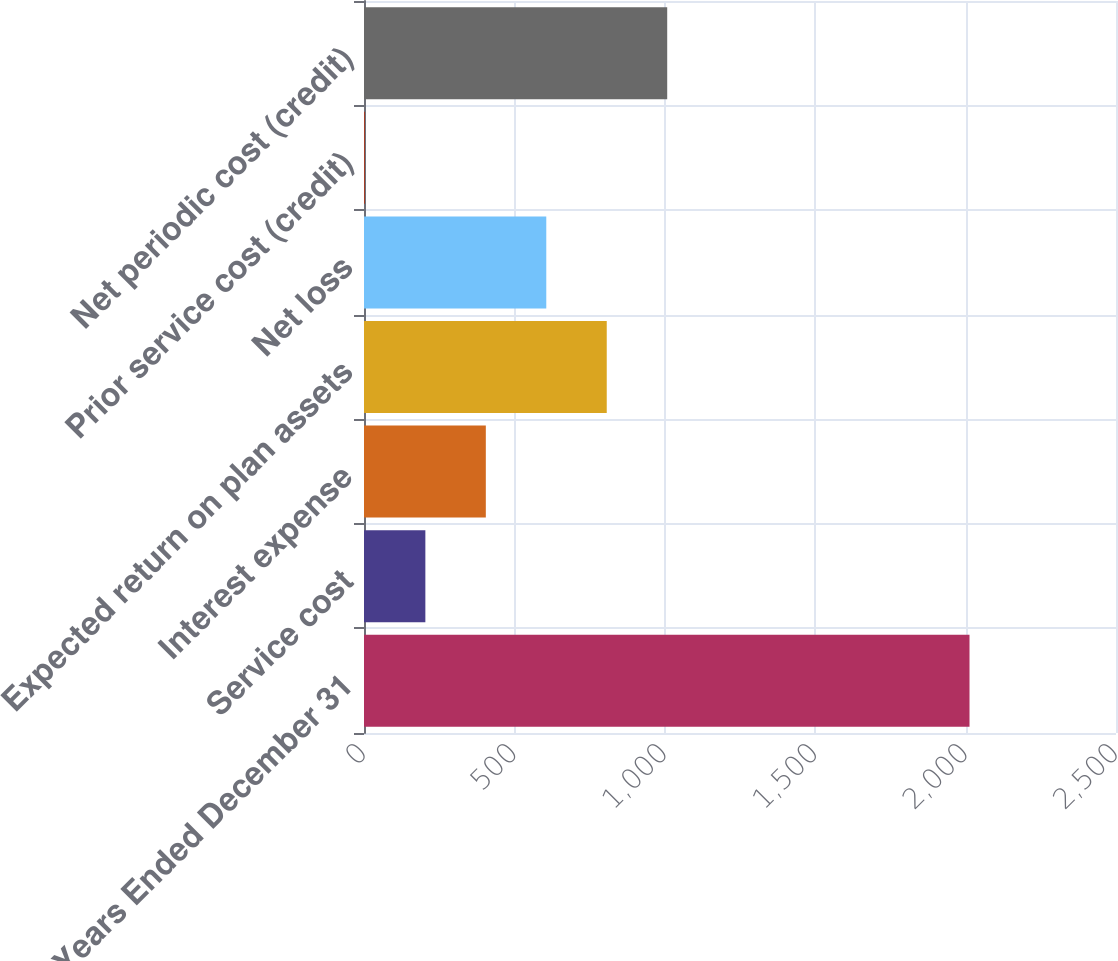Convert chart. <chart><loc_0><loc_0><loc_500><loc_500><bar_chart><fcel>Years Ended December 31<fcel>Service cost<fcel>Interest expense<fcel>Expected return on plan assets<fcel>Net loss<fcel>Prior service cost (credit)<fcel>Net periodic cost (credit)<nl><fcel>2013<fcel>204<fcel>405<fcel>807<fcel>606<fcel>3<fcel>1008<nl></chart> 